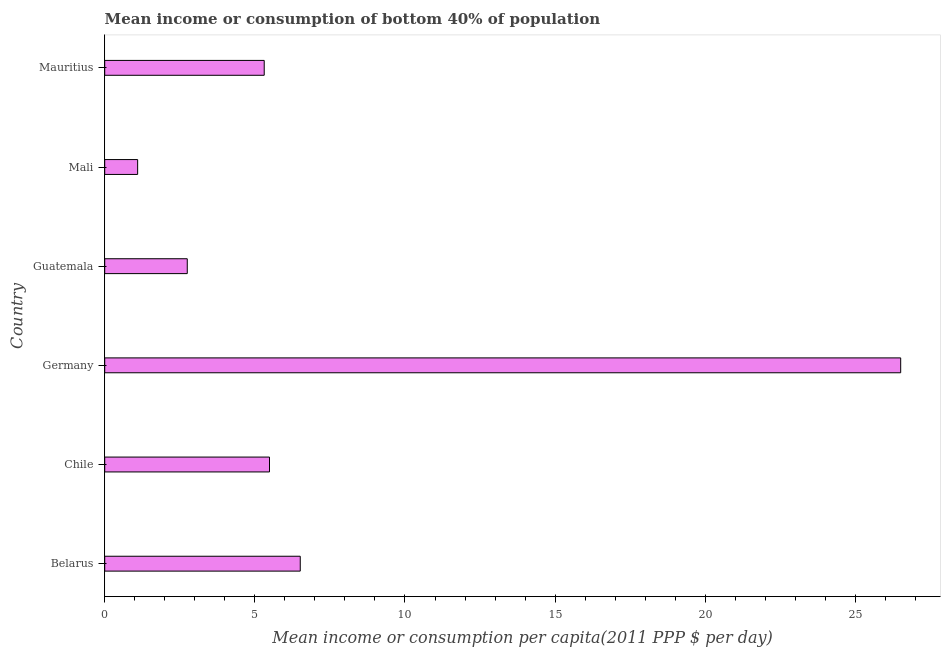Does the graph contain grids?
Offer a terse response. No. What is the title of the graph?
Ensure brevity in your answer.  Mean income or consumption of bottom 40% of population. What is the label or title of the X-axis?
Offer a very short reply. Mean income or consumption per capita(2011 PPP $ per day). What is the label or title of the Y-axis?
Your answer should be compact. Country. What is the mean income or consumption in Belarus?
Keep it short and to the point. 6.51. Across all countries, what is the maximum mean income or consumption?
Provide a short and direct response. 26.51. Across all countries, what is the minimum mean income or consumption?
Your answer should be very brief. 1.1. In which country was the mean income or consumption minimum?
Keep it short and to the point. Mali. What is the sum of the mean income or consumption?
Give a very brief answer. 47.67. What is the average mean income or consumption per country?
Your answer should be very brief. 7.94. What is the median mean income or consumption?
Offer a terse response. 5.4. In how many countries, is the mean income or consumption greater than 4 $?
Ensure brevity in your answer.  4. What is the ratio of the mean income or consumption in Mali to that in Mauritius?
Give a very brief answer. 0.21. Is the difference between the mean income or consumption in Chile and Mali greater than the difference between any two countries?
Your answer should be very brief. No. What is the difference between the highest and the second highest mean income or consumption?
Your answer should be very brief. 20. Is the sum of the mean income or consumption in Belarus and Mali greater than the maximum mean income or consumption across all countries?
Your response must be concise. No. What is the difference between the highest and the lowest mean income or consumption?
Provide a succinct answer. 25.41. In how many countries, is the mean income or consumption greater than the average mean income or consumption taken over all countries?
Give a very brief answer. 1. How many bars are there?
Your response must be concise. 6. How many countries are there in the graph?
Your answer should be compact. 6. Are the values on the major ticks of X-axis written in scientific E-notation?
Keep it short and to the point. No. What is the Mean income or consumption per capita(2011 PPP $ per day) in Belarus?
Keep it short and to the point. 6.51. What is the Mean income or consumption per capita(2011 PPP $ per day) of Chile?
Make the answer very short. 5.49. What is the Mean income or consumption per capita(2011 PPP $ per day) in Germany?
Ensure brevity in your answer.  26.51. What is the Mean income or consumption per capita(2011 PPP $ per day) of Guatemala?
Make the answer very short. 2.75. What is the Mean income or consumption per capita(2011 PPP $ per day) in Mali?
Your answer should be very brief. 1.1. What is the Mean income or consumption per capita(2011 PPP $ per day) in Mauritius?
Offer a very short reply. 5.31. What is the difference between the Mean income or consumption per capita(2011 PPP $ per day) in Belarus and Chile?
Keep it short and to the point. 1.02. What is the difference between the Mean income or consumption per capita(2011 PPP $ per day) in Belarus and Germany?
Your answer should be very brief. -20. What is the difference between the Mean income or consumption per capita(2011 PPP $ per day) in Belarus and Guatemala?
Offer a terse response. 3.76. What is the difference between the Mean income or consumption per capita(2011 PPP $ per day) in Belarus and Mali?
Provide a short and direct response. 5.42. What is the difference between the Mean income or consumption per capita(2011 PPP $ per day) in Belarus and Mauritius?
Offer a terse response. 1.2. What is the difference between the Mean income or consumption per capita(2011 PPP $ per day) in Chile and Germany?
Your answer should be compact. -21.02. What is the difference between the Mean income or consumption per capita(2011 PPP $ per day) in Chile and Guatemala?
Your answer should be very brief. 2.74. What is the difference between the Mean income or consumption per capita(2011 PPP $ per day) in Chile and Mali?
Provide a short and direct response. 4.39. What is the difference between the Mean income or consumption per capita(2011 PPP $ per day) in Chile and Mauritius?
Provide a short and direct response. 0.18. What is the difference between the Mean income or consumption per capita(2011 PPP $ per day) in Germany and Guatemala?
Ensure brevity in your answer.  23.76. What is the difference between the Mean income or consumption per capita(2011 PPP $ per day) in Germany and Mali?
Your response must be concise. 25.41. What is the difference between the Mean income or consumption per capita(2011 PPP $ per day) in Germany and Mauritius?
Provide a short and direct response. 21.2. What is the difference between the Mean income or consumption per capita(2011 PPP $ per day) in Guatemala and Mali?
Your answer should be very brief. 1.65. What is the difference between the Mean income or consumption per capita(2011 PPP $ per day) in Guatemala and Mauritius?
Provide a succinct answer. -2.56. What is the difference between the Mean income or consumption per capita(2011 PPP $ per day) in Mali and Mauritius?
Your answer should be very brief. -4.22. What is the ratio of the Mean income or consumption per capita(2011 PPP $ per day) in Belarus to that in Chile?
Your answer should be very brief. 1.19. What is the ratio of the Mean income or consumption per capita(2011 PPP $ per day) in Belarus to that in Germany?
Offer a terse response. 0.25. What is the ratio of the Mean income or consumption per capita(2011 PPP $ per day) in Belarus to that in Guatemala?
Offer a terse response. 2.37. What is the ratio of the Mean income or consumption per capita(2011 PPP $ per day) in Belarus to that in Mali?
Your answer should be compact. 5.94. What is the ratio of the Mean income or consumption per capita(2011 PPP $ per day) in Belarus to that in Mauritius?
Give a very brief answer. 1.23. What is the ratio of the Mean income or consumption per capita(2011 PPP $ per day) in Chile to that in Germany?
Offer a very short reply. 0.21. What is the ratio of the Mean income or consumption per capita(2011 PPP $ per day) in Chile to that in Guatemala?
Make the answer very short. 2. What is the ratio of the Mean income or consumption per capita(2011 PPP $ per day) in Chile to that in Mali?
Give a very brief answer. 5. What is the ratio of the Mean income or consumption per capita(2011 PPP $ per day) in Chile to that in Mauritius?
Make the answer very short. 1.03. What is the ratio of the Mean income or consumption per capita(2011 PPP $ per day) in Germany to that in Guatemala?
Provide a succinct answer. 9.64. What is the ratio of the Mean income or consumption per capita(2011 PPP $ per day) in Germany to that in Mali?
Your response must be concise. 24.18. What is the ratio of the Mean income or consumption per capita(2011 PPP $ per day) in Germany to that in Mauritius?
Make the answer very short. 4.99. What is the ratio of the Mean income or consumption per capita(2011 PPP $ per day) in Guatemala to that in Mali?
Offer a very short reply. 2.51. What is the ratio of the Mean income or consumption per capita(2011 PPP $ per day) in Guatemala to that in Mauritius?
Your response must be concise. 0.52. What is the ratio of the Mean income or consumption per capita(2011 PPP $ per day) in Mali to that in Mauritius?
Offer a very short reply. 0.21. 